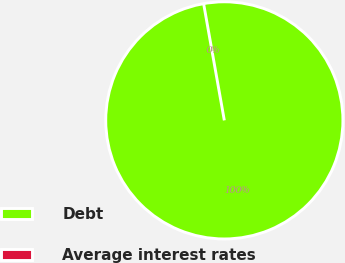<chart> <loc_0><loc_0><loc_500><loc_500><pie_chart><fcel>Debt<fcel>Average interest rates<nl><fcel>100.0%<fcel>0.0%<nl></chart> 